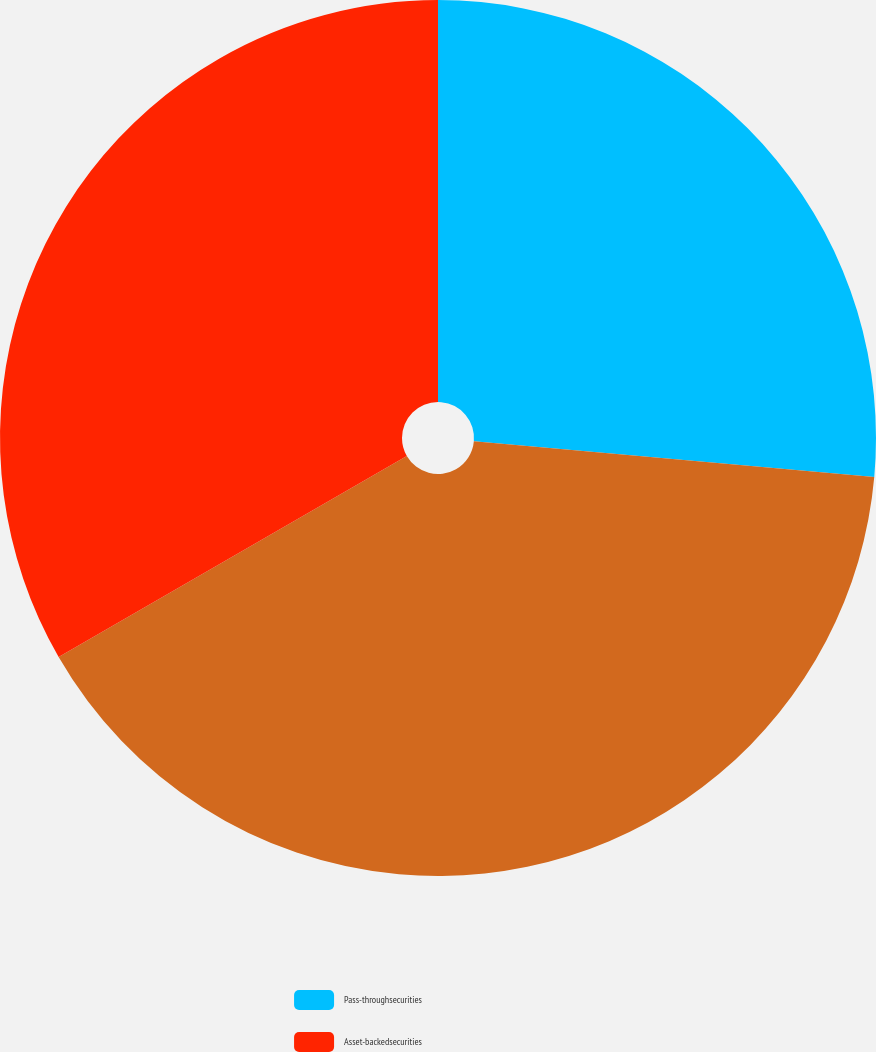Convert chart to OTSL. <chart><loc_0><loc_0><loc_500><loc_500><pie_chart><fcel>Pass-throughsecurities<fcel>Unnamed: 1<fcel>Asset-backedsecurities<nl><fcel>26.42%<fcel>40.25%<fcel>33.33%<nl></chart> 